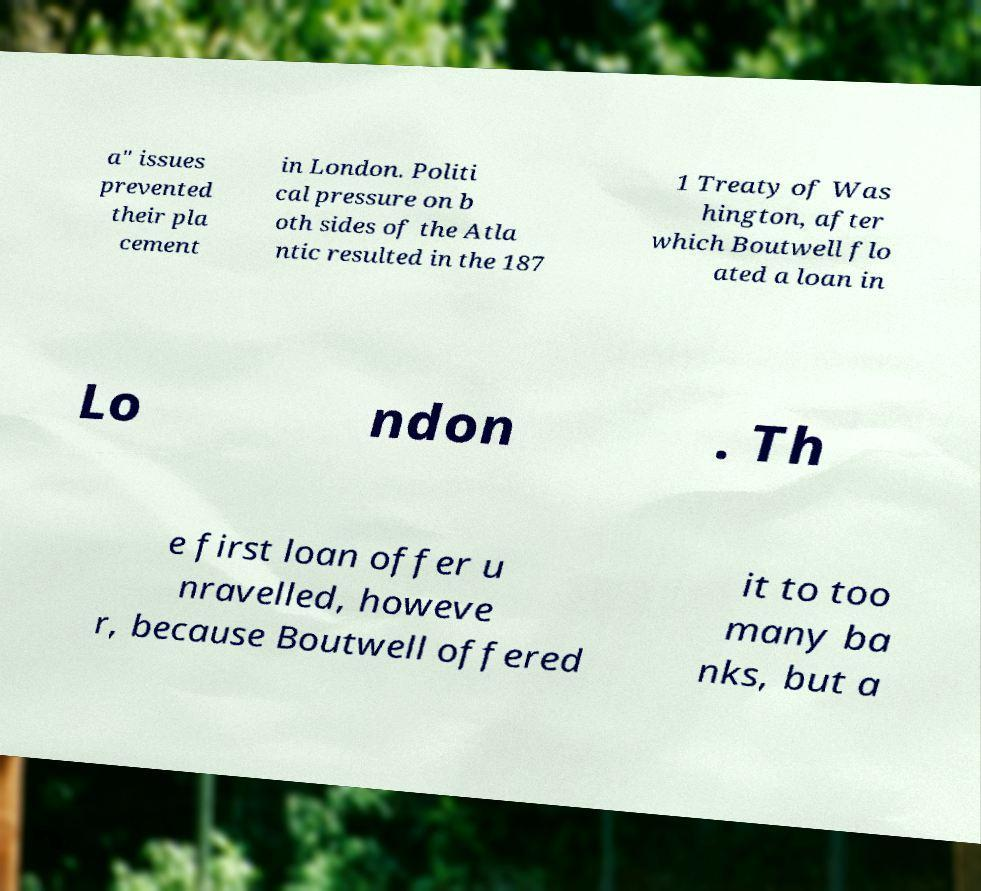Can you accurately transcribe the text from the provided image for me? a" issues prevented their pla cement in London. Politi cal pressure on b oth sides of the Atla ntic resulted in the 187 1 Treaty of Was hington, after which Boutwell flo ated a loan in Lo ndon . Th e first loan offer u nravelled, howeve r, because Boutwell offered it to too many ba nks, but a 